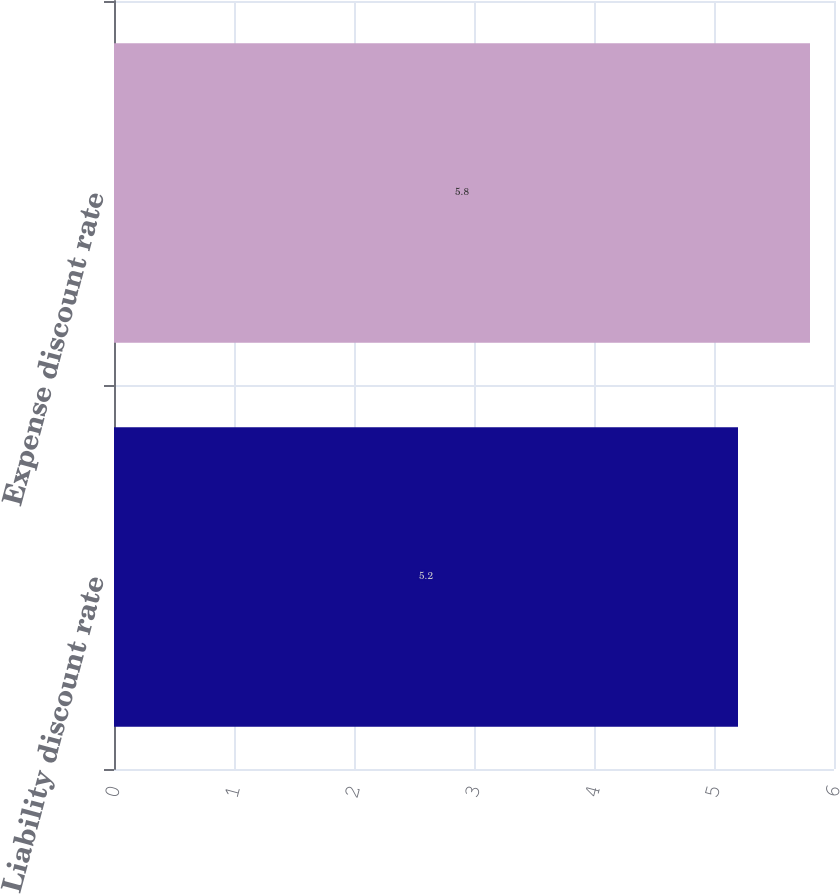<chart> <loc_0><loc_0><loc_500><loc_500><bar_chart><fcel>Liability discount rate<fcel>Expense discount rate<nl><fcel>5.2<fcel>5.8<nl></chart> 